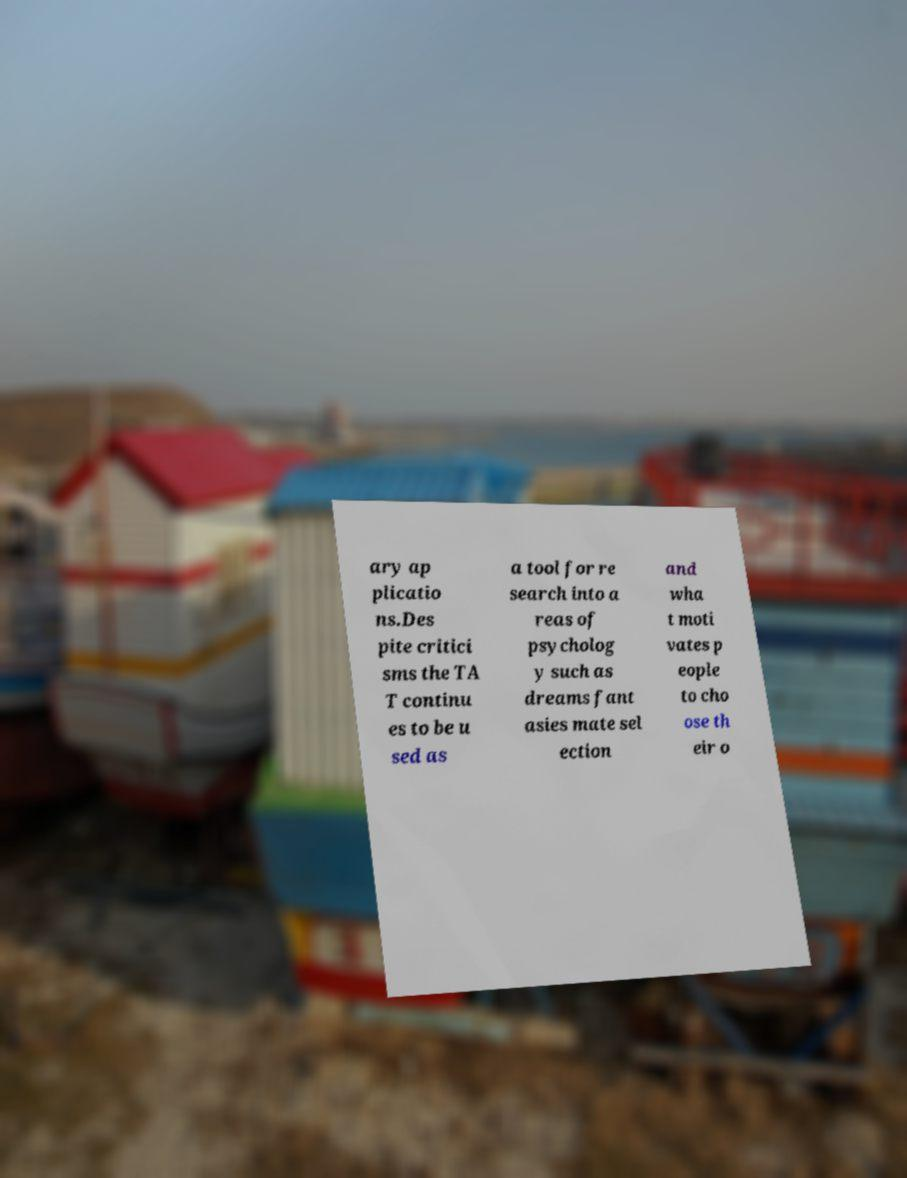Can you accurately transcribe the text from the provided image for me? ary ap plicatio ns.Des pite critici sms the TA T continu es to be u sed as a tool for re search into a reas of psycholog y such as dreams fant asies mate sel ection and wha t moti vates p eople to cho ose th eir o 